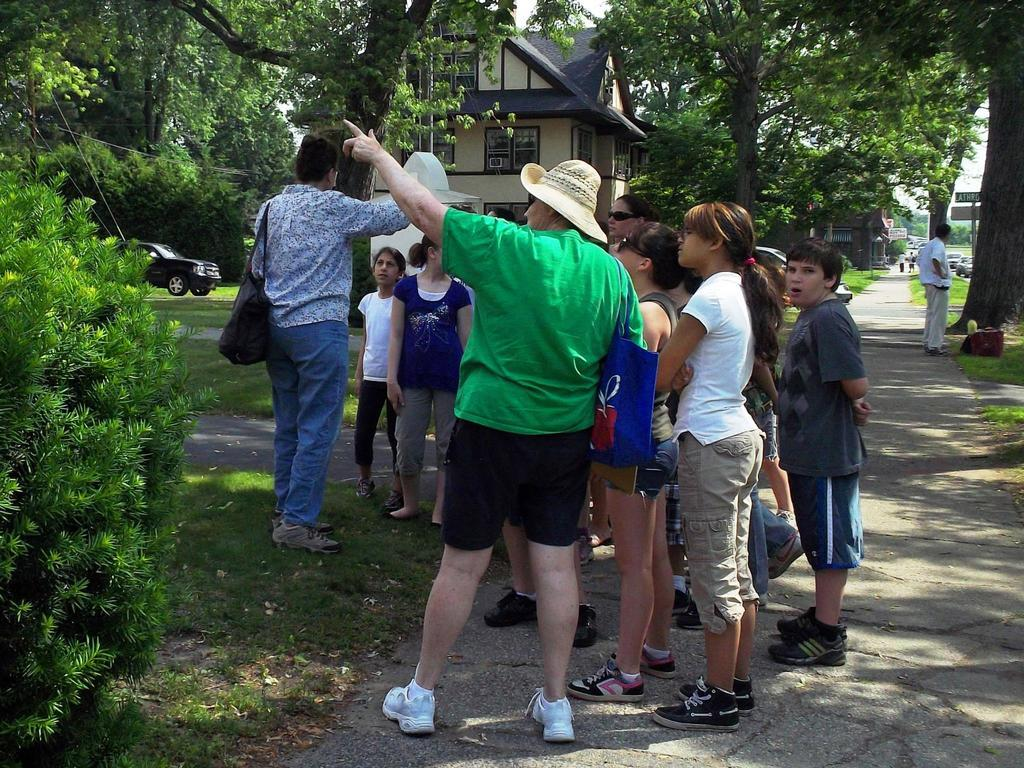What can be seen in the image? There are people standing in the image. What is visible in the background of the image? There are buildings and trees in the background of the image. What type of vehicles are present in the image? Cars are present in the image. What type of ground is visible at the bottom of the image? There is grass at the bottom of the image. What type of legal advice can be seen being given in the image? There is no lawyer or legal advice present in the image. What type of facial expression can be seen on the trees in the image? Trees do not have facial expressions, as they are inanimate objects. 